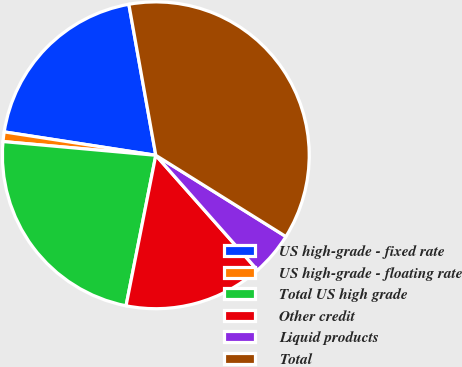Convert chart to OTSL. <chart><loc_0><loc_0><loc_500><loc_500><pie_chart><fcel>US high-grade - fixed rate<fcel>US high-grade - floating rate<fcel>Total US high grade<fcel>Other credit<fcel>Liquid products<fcel>Total<nl><fcel>19.75%<fcel>1.01%<fcel>23.32%<fcel>14.64%<fcel>4.58%<fcel>36.7%<nl></chart> 